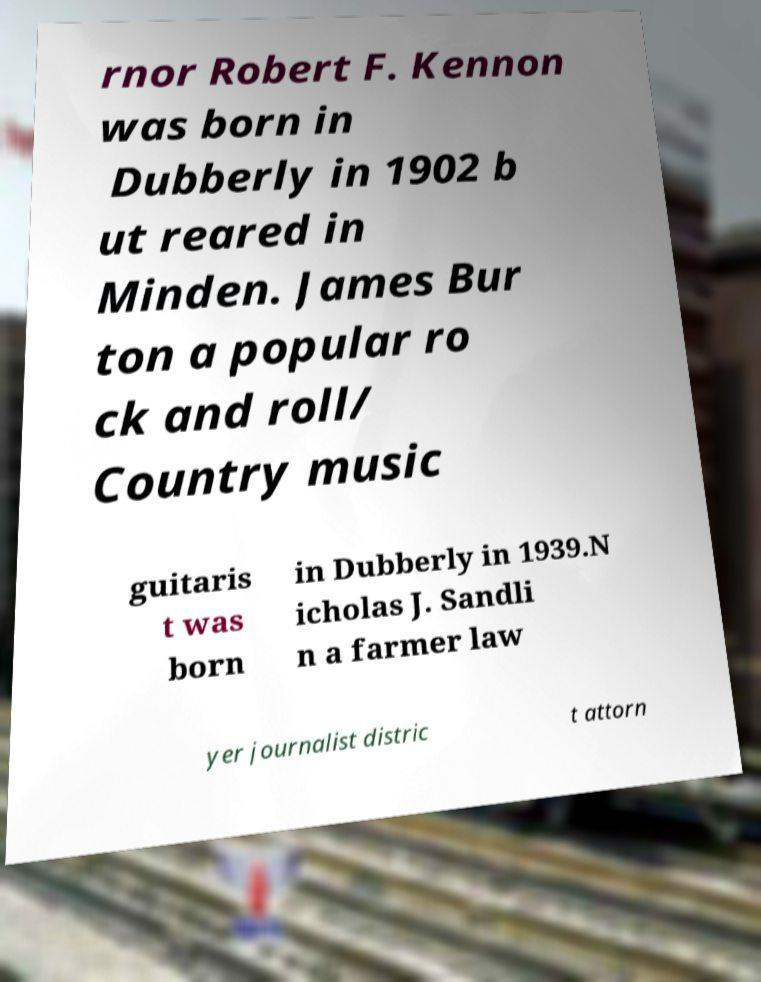Could you assist in decoding the text presented in this image and type it out clearly? rnor Robert F. Kennon was born in Dubberly in 1902 b ut reared in Minden. James Bur ton a popular ro ck and roll/ Country music guitaris t was born in Dubberly in 1939.N icholas J. Sandli n a farmer law yer journalist distric t attorn 